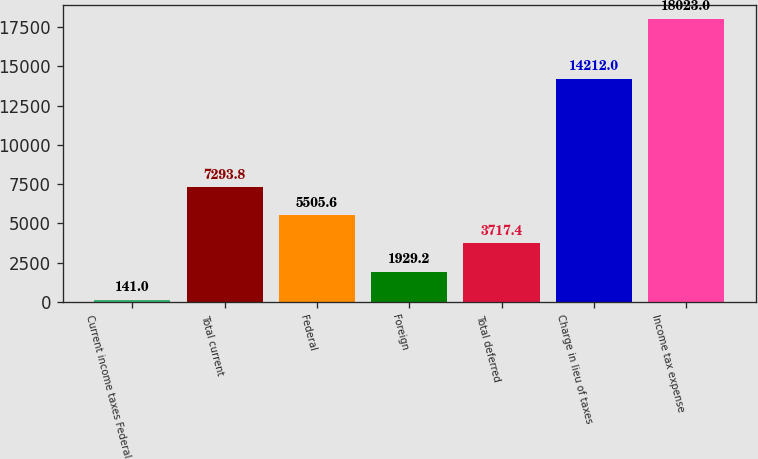Convert chart to OTSL. <chart><loc_0><loc_0><loc_500><loc_500><bar_chart><fcel>Current income taxes Federal<fcel>Total current<fcel>Federal<fcel>Foreign<fcel>Total deferred<fcel>Charge in lieu of taxes<fcel>Income tax expense<nl><fcel>141<fcel>7293.8<fcel>5505.6<fcel>1929.2<fcel>3717.4<fcel>14212<fcel>18023<nl></chart> 